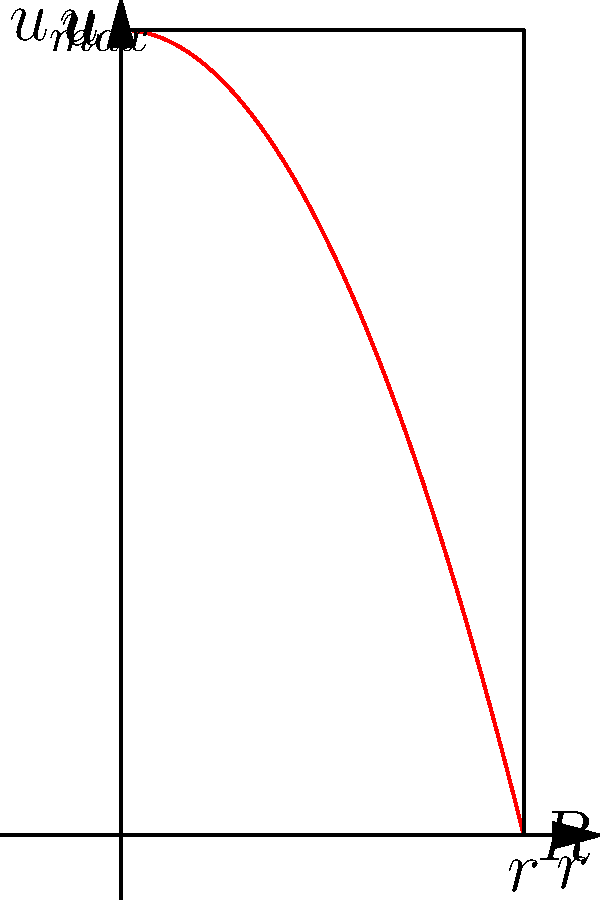In a laminar flow through a pipe, the velocity profile is parabolic as shown in the graph. If you were to capture this flow using multiple camera angles, which mathematical expression would best represent the velocity $u$ as a function of radial position $r$, where $R$ is the pipe radius and $u_{max}$ is the maximum velocity at the center? To determine the mathematical expression for the velocity profile, let's follow these steps:

1. Observe the parabolic shape of the velocity profile in the graph.

2. Note that the velocity is maximum ($u_{max}$) at the center of the pipe ($r = 0$) and zero at the pipe wall ($r = R$).

3. The general equation for a parabola is of the form $y = a(x - h)^2 + k$, where $(h, k)$ is the vertex of the parabola.

4. In our case, the vertex is at $(0, u_{max})$, so $h = 0$ and $k = u_{max}$.

5. The parabola passes through the points $(0, u_{max})$ and $(R, 0)$. We can use these to determine the coefficient $a$.

6. Substituting the point $(R, 0)$ into the equation:
   $0 = aR^2 + u_{max}$
   $a = -\frac{u_{max}}{R^2}$

7. Therefore, the equation of the parabola is:
   $u = -\frac{u_{max}}{R^2}r^2 + u_{max}$

8. Rearranging to a more standard form:
   $u = u_{max}(1 - \frac{r^2}{R^2})$

This equation represents the velocity $u$ as a function of radial position $r$, with $u_{max}$ as the maximum velocity at the center and $R$ as the pipe radius.
Answer: $u = u_{max}(1 - \frac{r^2}{R^2})$ 